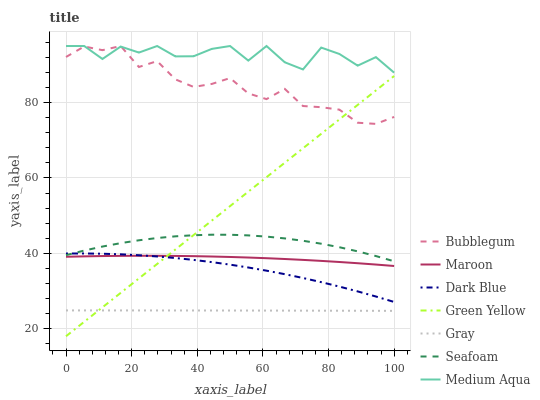Does Gray have the minimum area under the curve?
Answer yes or no. Yes. Does Medium Aqua have the maximum area under the curve?
Answer yes or no. Yes. Does Seafoam have the minimum area under the curve?
Answer yes or no. No. Does Seafoam have the maximum area under the curve?
Answer yes or no. No. Is Green Yellow the smoothest?
Answer yes or no. Yes. Is Medium Aqua the roughest?
Answer yes or no. Yes. Is Seafoam the smoothest?
Answer yes or no. No. Is Seafoam the roughest?
Answer yes or no. No. Does Green Yellow have the lowest value?
Answer yes or no. Yes. Does Seafoam have the lowest value?
Answer yes or no. No. Does Bubblegum have the highest value?
Answer yes or no. Yes. Does Seafoam have the highest value?
Answer yes or no. No. Is Gray less than Seafoam?
Answer yes or no. Yes. Is Seafoam greater than Maroon?
Answer yes or no. Yes. Does Maroon intersect Green Yellow?
Answer yes or no. Yes. Is Maroon less than Green Yellow?
Answer yes or no. No. Is Maroon greater than Green Yellow?
Answer yes or no. No. Does Gray intersect Seafoam?
Answer yes or no. No. 